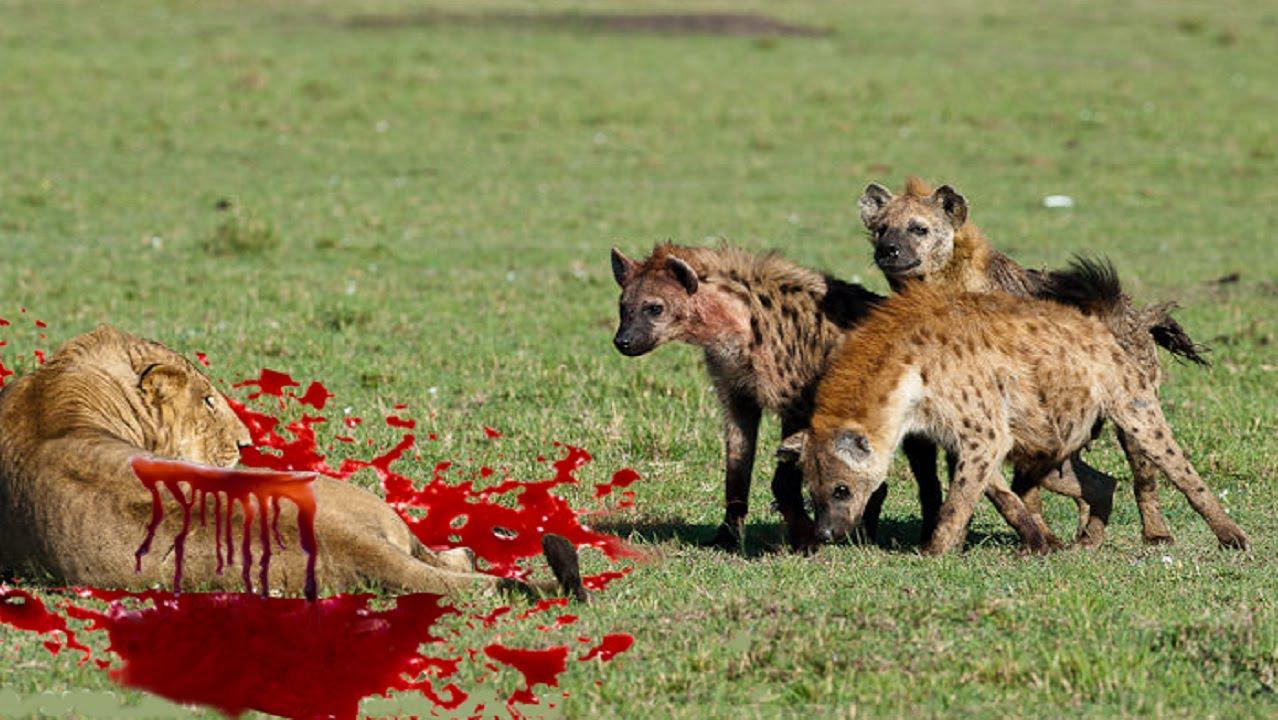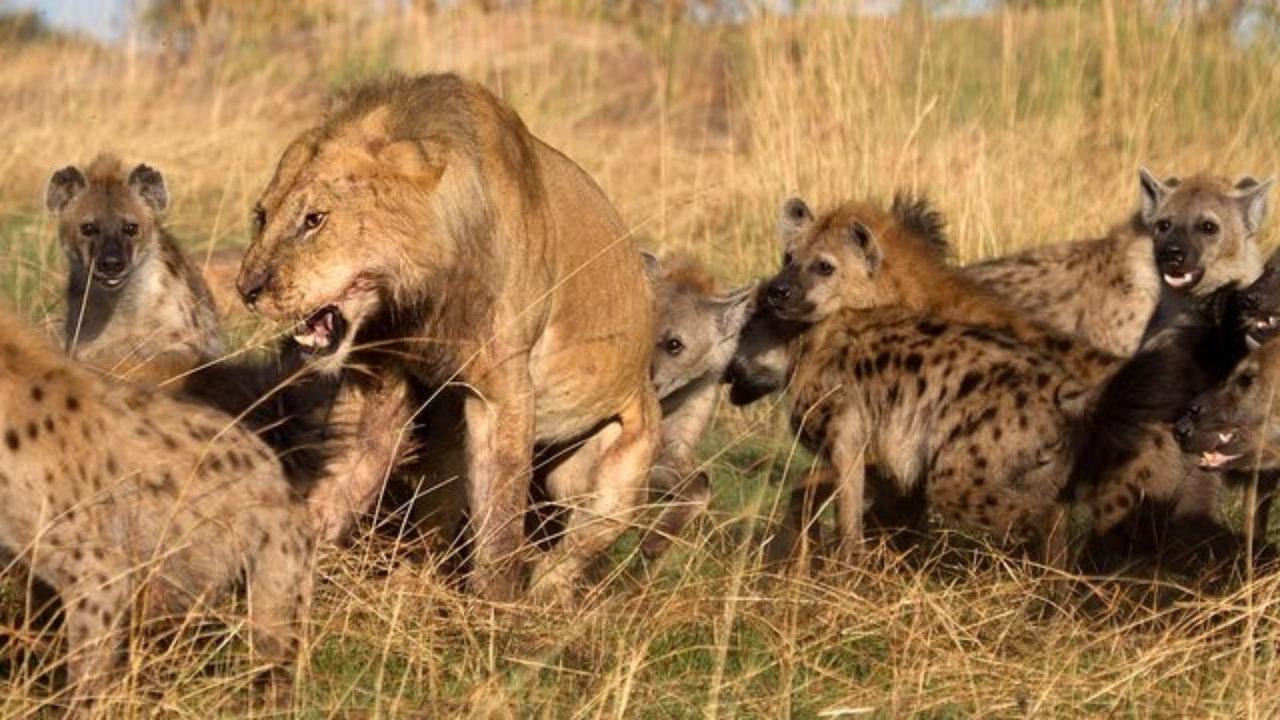The first image is the image on the left, the second image is the image on the right. Considering the images on both sides, is "At least one hyena is facing right and showing teeth." valid? Answer yes or no. No. 